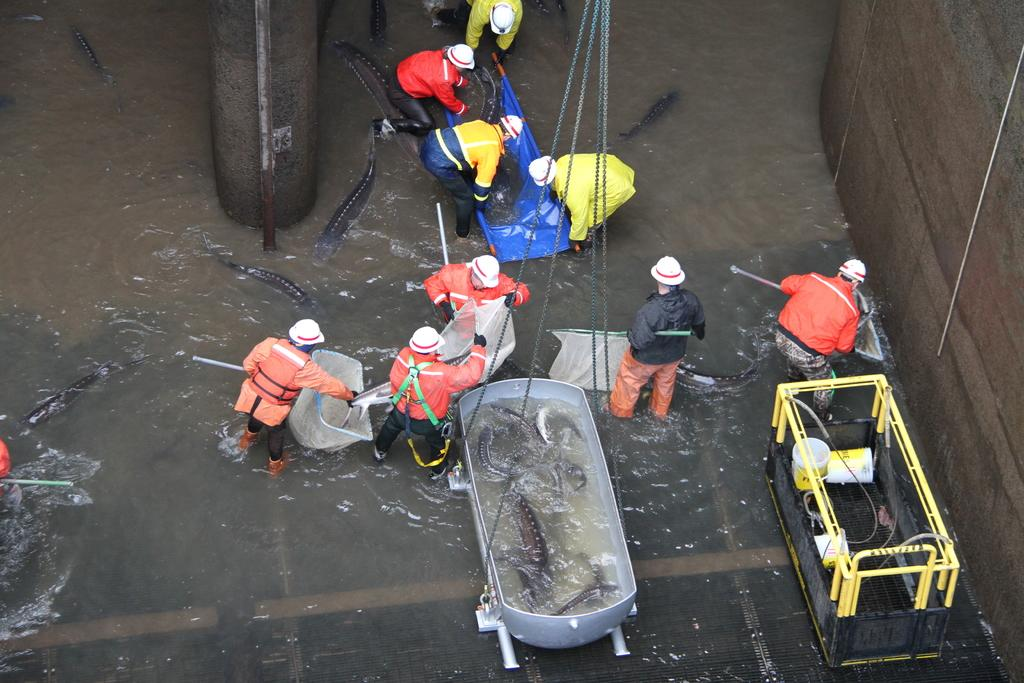How many people are in the image? There is a group of people in the image, but the exact number is not specified. What are the people doing in the image? The people are catching fishes from the water. What other objects can be seen in the image? There are machines, a wall, metal rods, lifters, and nets in the image. Can you describe the setting of the image? The image may have been taken in or near the water, as the people are catching fishes. What type of collar can be seen on the governor in the image? There is no governor or collar present in the image. 